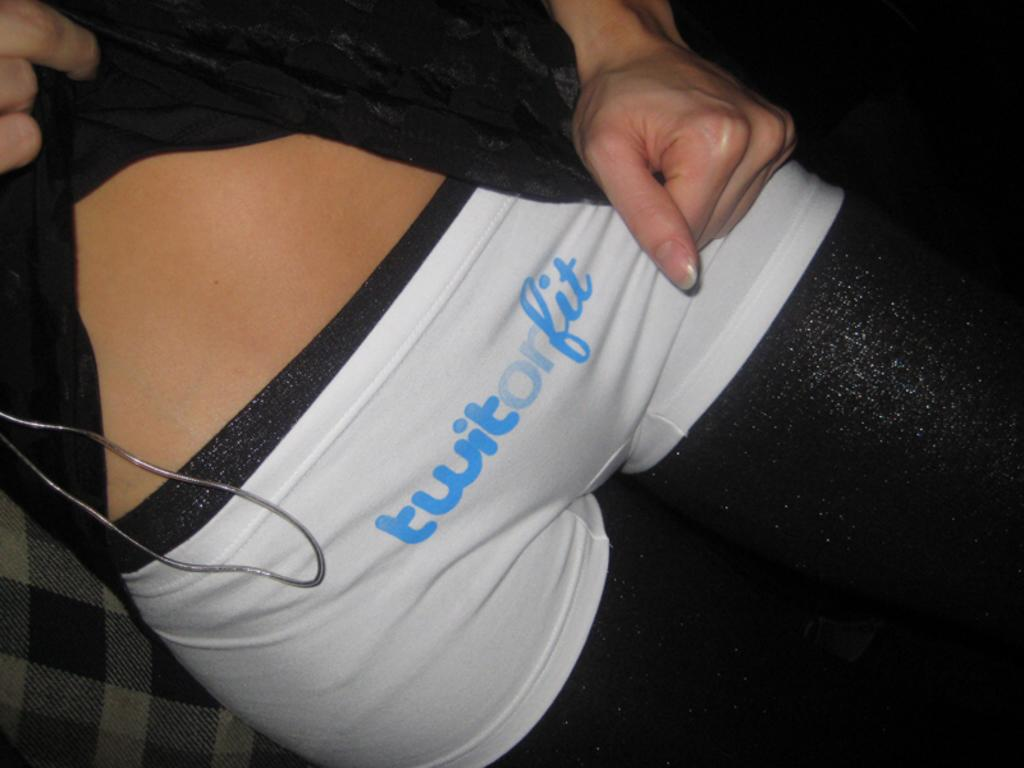<image>
Create a compact narrative representing the image presented. Underwear with blue letters that says "twitorfit" on it. 